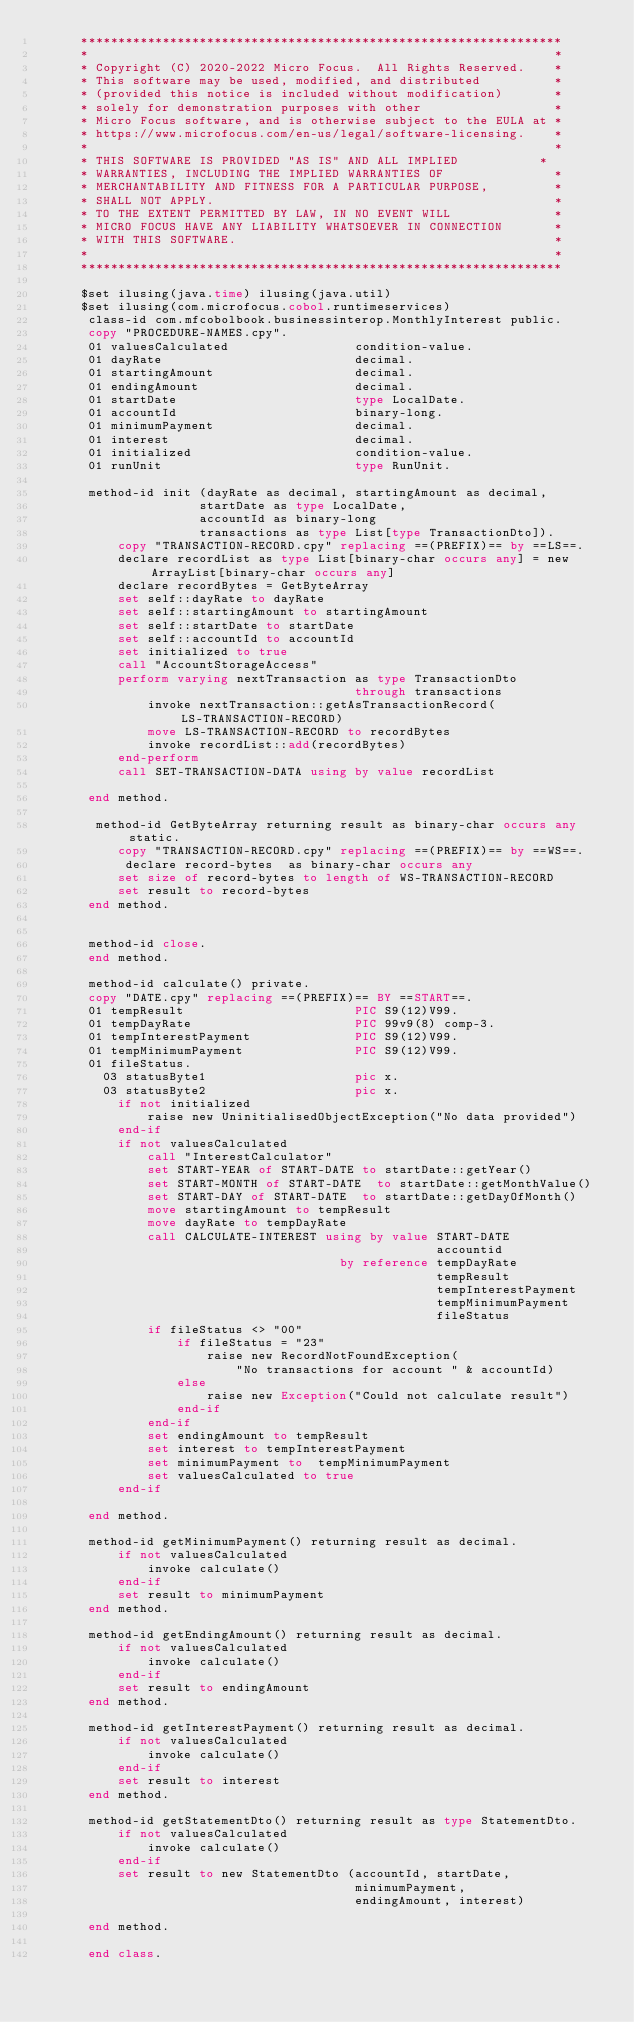<code> <loc_0><loc_0><loc_500><loc_500><_COBOL_>      *****************************************************************
      *                                                               *
      * Copyright (C) 2020-2022 Micro Focus.  All Rights Reserved.    *
      * This software may be used, modified, and distributed          *
      * (provided this notice is included without modification)       *
      * solely for demonstration purposes with other                  *
      * Micro Focus software, and is otherwise subject to the EULA at *
      * https://www.microfocus.com/en-us/legal/software-licensing.    *
      *                                                               *
      * THIS SOFTWARE IS PROVIDED "AS IS" AND ALL IMPLIED           *
      * WARRANTIES, INCLUDING THE IMPLIED WARRANTIES OF               *
      * MERCHANTABILITY AND FITNESS FOR A PARTICULAR PURPOSE,         *
      * SHALL NOT APPLY.                                              *
      * TO THE EXTENT PERMITTED BY LAW, IN NO EVENT WILL              *
      * MICRO FOCUS HAVE ANY LIABILITY WHATSOEVER IN CONNECTION       *
      * WITH THIS SOFTWARE.                                           *
      *                                                               *
      *****************************************************************
      
      $set ilusing(java.time) ilusing(java.util)
      $set ilusing(com.microfocus.cobol.runtimeservices) 
       class-id com.mfcobolbook.businessinterop.MonthlyInterest public. 
       copy "PROCEDURE-NAMES.cpy".
       01 valuesCalculated                 condition-value.
       01 dayRate                          decimal.
       01 startingAmount                   decimal. 
       01 endingAmount                     decimal. 
       01 startDate                        type LocalDate. 
       01 accountId                        binary-long.
       01 minimumPayment                   decimal. 
       01 interest                         decimal. 
       01 initialized                      condition-value. 
       01 runUnit                          type RunUnit.
       
       method-id init (dayRate as decimal, startingAmount as decimal, 
                      startDate as type LocalDate, 
                      accountId as binary-long
                      transactions as type List[type TransactionDto]).
           copy "TRANSACTION-RECORD.cpy" replacing ==(PREFIX)== by ==LS==. 
           declare recordList as type List[binary-char occurs any] = new ArrayList[binary-char occurs any]
           declare recordBytes = GetByteArray 
           set self::dayRate to dayRate
           set self::startingAmount to startingAmount
           set self::startDate to startDate
           set self::accountId to accountId
           set initialized to true
           call "AccountStorageAccess"
           perform varying nextTransaction as type TransactionDto 
                                           through transactions
               invoke nextTransaction::getAsTransactionRecord(LS-TRANSACTION-RECORD)
               move LS-TRANSACTION-RECORD to recordBytes 
               invoke recordList::add(recordBytes)
           end-perform
           call SET-TRANSACTION-DATA using by value recordList     
           
       end method. 

        method-id GetByteArray returning result as binary-char occurs any static.
           copy "TRANSACTION-RECORD.cpy" replacing ==(PREFIX)== by ==WS==. 
            declare record-bytes  as binary-char occurs any
           set size of record-bytes to length of WS-TRANSACTION-RECORD     
           set result to record-bytes 
       end method.

       
       method-id close. 
       end method. 
       
       method-id calculate() private.
       copy "DATE.cpy" replacing ==(PREFIX)== BY ==START==. 
       01 tempResult                       PIC S9(12)V99. 
       01 tempDayRate                      PIC 99v9(8) comp-3.
       01 tempInterestPayment              PIC S9(12)V99.
       01 tempMinimumPayment               PIC S9(12)V99.
       01 fileStatus. 
         03 statusByte1                    pic x.
         03 statusByte2                    pic x.
           if not initialized 
               raise new UninitialisedObjectException("No data provided")
           end-if
           if not valuesCalculated
               call "InterestCalculator"
               set START-YEAR of START-DATE to startDate::getYear()
               set START-MONTH of START-DATE  to startDate::getMonthValue() 
               set START-DAY of START-DATE  to startDate::getDayOfMonth()
               move startingAmount to tempResult
               move dayRate to tempDayRate
               call CALCULATE-INTEREST using by value START-DATE
                                                      accountid
                                         by reference tempDayRate 
                                                      tempResult 
                                                      tempInterestPayment
                                                      tempMinimumPayment 
                                                      fileStatus
               if fileStatus <> "00"
                   if fileStatus = "23"
                       raise new RecordNotFoundException(
                           "No transactions for account " & accountId)
                   else
                       raise new Exception("Could not calculate result")
                   end-if
               end-if
               set endingAmount to tempResult
               set interest to tempInterestPayment
               set minimumPayment to  tempMinimumPayment
               set valuesCalculated to true 
           end-if 
           
       end method. 
       
       method-id getMinimumPayment() returning result as decimal. 
           if not valuesCalculated
               invoke calculate()
           end-if
           set result to minimumPayment
       end method.
       
       method-id getEndingAmount() returning result as decimal. 
           if not valuesCalculated
               invoke calculate()
           end-if
           set result to endingAmount
       end method.
       
       method-id getInterestPayment() returning result as decimal.
           if not valuesCalculated
               invoke calculate()
           end-if
           set result to interest 
       end method.
       
       method-id getStatementDto() returning result as type StatementDto. 
           if not valuesCalculated
               invoke calculate()
           end-if
           set result to new StatementDto (accountId, startDate, 
                                           minimumPayment,
                                           endingAmount, interest) 
           
       end method. 
       
       end class.
</code> 